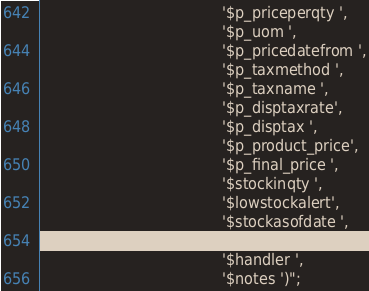Convert code to text. <code><loc_0><loc_0><loc_500><loc_500><_PHP_>										'$p_priceperqty ',
										'$p_uom ',
										'$p_pricedatefrom ',
										'$p_taxmethod ',
										'$p_taxname ',
										'$p_disptaxrate', 
										'$p_disptax ',
										'$p_product_price', 
										'$p_final_price ',
										'$stockinqty ',
										'$lowstockalert', 
										'$stockasofdate ',
										'$vendor ',
										'$handler ',
										'$notes ')";
</code> 